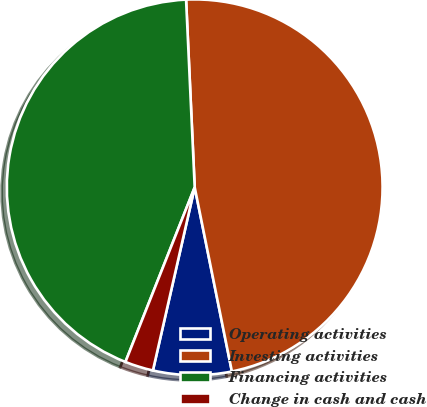Convert chart. <chart><loc_0><loc_0><loc_500><loc_500><pie_chart><fcel>Operating activities<fcel>Investing activities<fcel>Financing activities<fcel>Change in cash and cash<nl><fcel>6.74%<fcel>47.56%<fcel>43.26%<fcel>2.44%<nl></chart> 